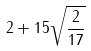<formula> <loc_0><loc_0><loc_500><loc_500>2 + 1 5 \sqrt { \frac { 2 } { 1 7 } }</formula> 